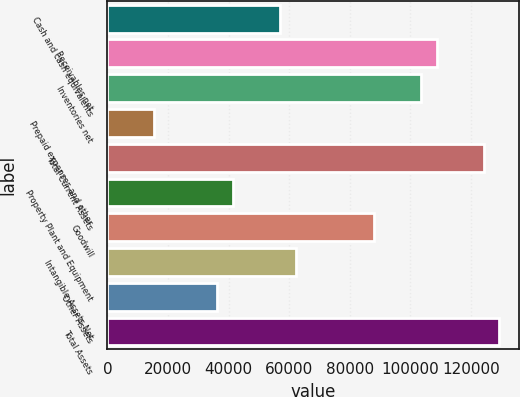<chart> <loc_0><loc_0><loc_500><loc_500><bar_chart><fcel>Cash and cash equivalents<fcel>Receivables net<fcel>Inventories net<fcel>Prepaid expenses and other<fcel>Total Current Assets<fcel>Property Plant and Equipment<fcel>Goodwill<fcel>Intangible Assets Net<fcel>Other Assets<fcel>Total Assets<nl><fcel>56934.6<fcel>108691<fcel>103515<fcel>15529.8<fcel>124217<fcel>41407.8<fcel>87988.2<fcel>62110.2<fcel>36232.2<fcel>129393<nl></chart> 